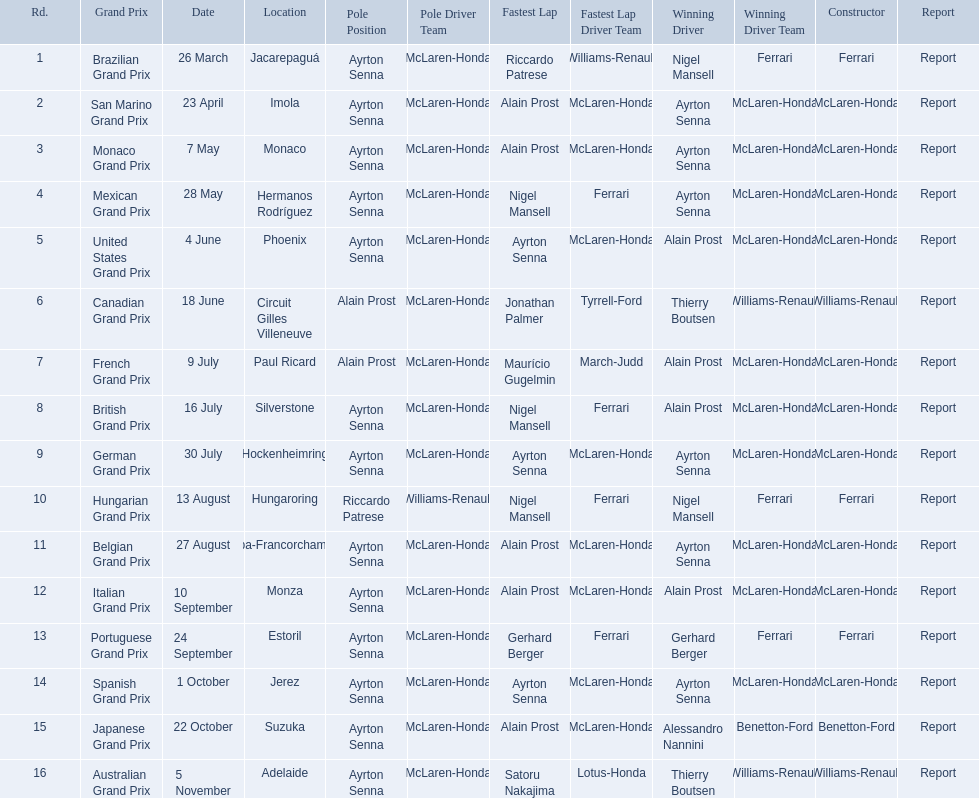What are all of the grand prix run in the 1989 formula one season? Brazilian Grand Prix, San Marino Grand Prix, Monaco Grand Prix, Mexican Grand Prix, United States Grand Prix, Canadian Grand Prix, French Grand Prix, British Grand Prix, German Grand Prix, Hungarian Grand Prix, Belgian Grand Prix, Italian Grand Prix, Portuguese Grand Prix, Spanish Grand Prix, Japanese Grand Prix, Australian Grand Prix. Of those 1989 formula one grand prix, which were run in october? Spanish Grand Prix, Japanese Grand Prix, Australian Grand Prix. Of those 1989 formula one grand prix run in october, which was the only one to be won by benetton-ford? Japanese Grand Prix. 